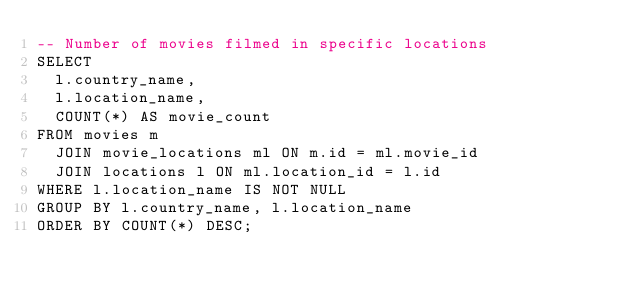Convert code to text. <code><loc_0><loc_0><loc_500><loc_500><_SQL_>-- Number of movies filmed in specific locations
SELECT
  l.country_name,
  l.location_name,
  COUNT(*) AS movie_count
FROM movies m
  JOIN movie_locations ml ON m.id = ml.movie_id
  JOIN locations l ON ml.location_id = l.id
WHERE l.location_name IS NOT NULL
GROUP BY l.country_name, l.location_name
ORDER BY COUNT(*) DESC;
</code> 